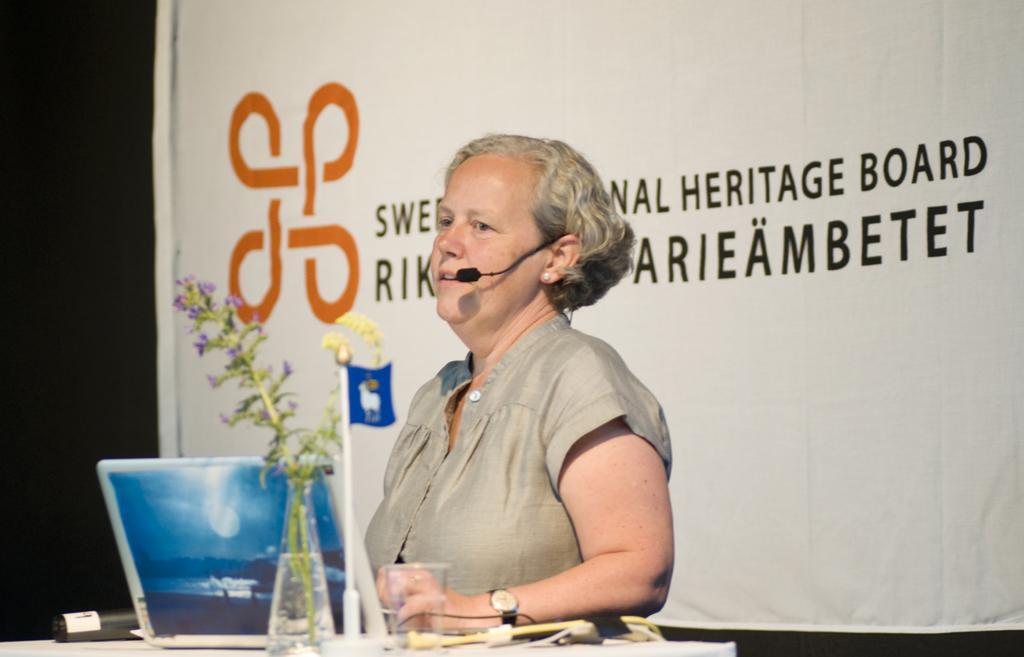Could you give a brief overview of what you see in this image? In this image a lady speaks into the microphone. There is a laptop and other objects which are placed on the table. There is a banner behind the lady on which some text is written. 